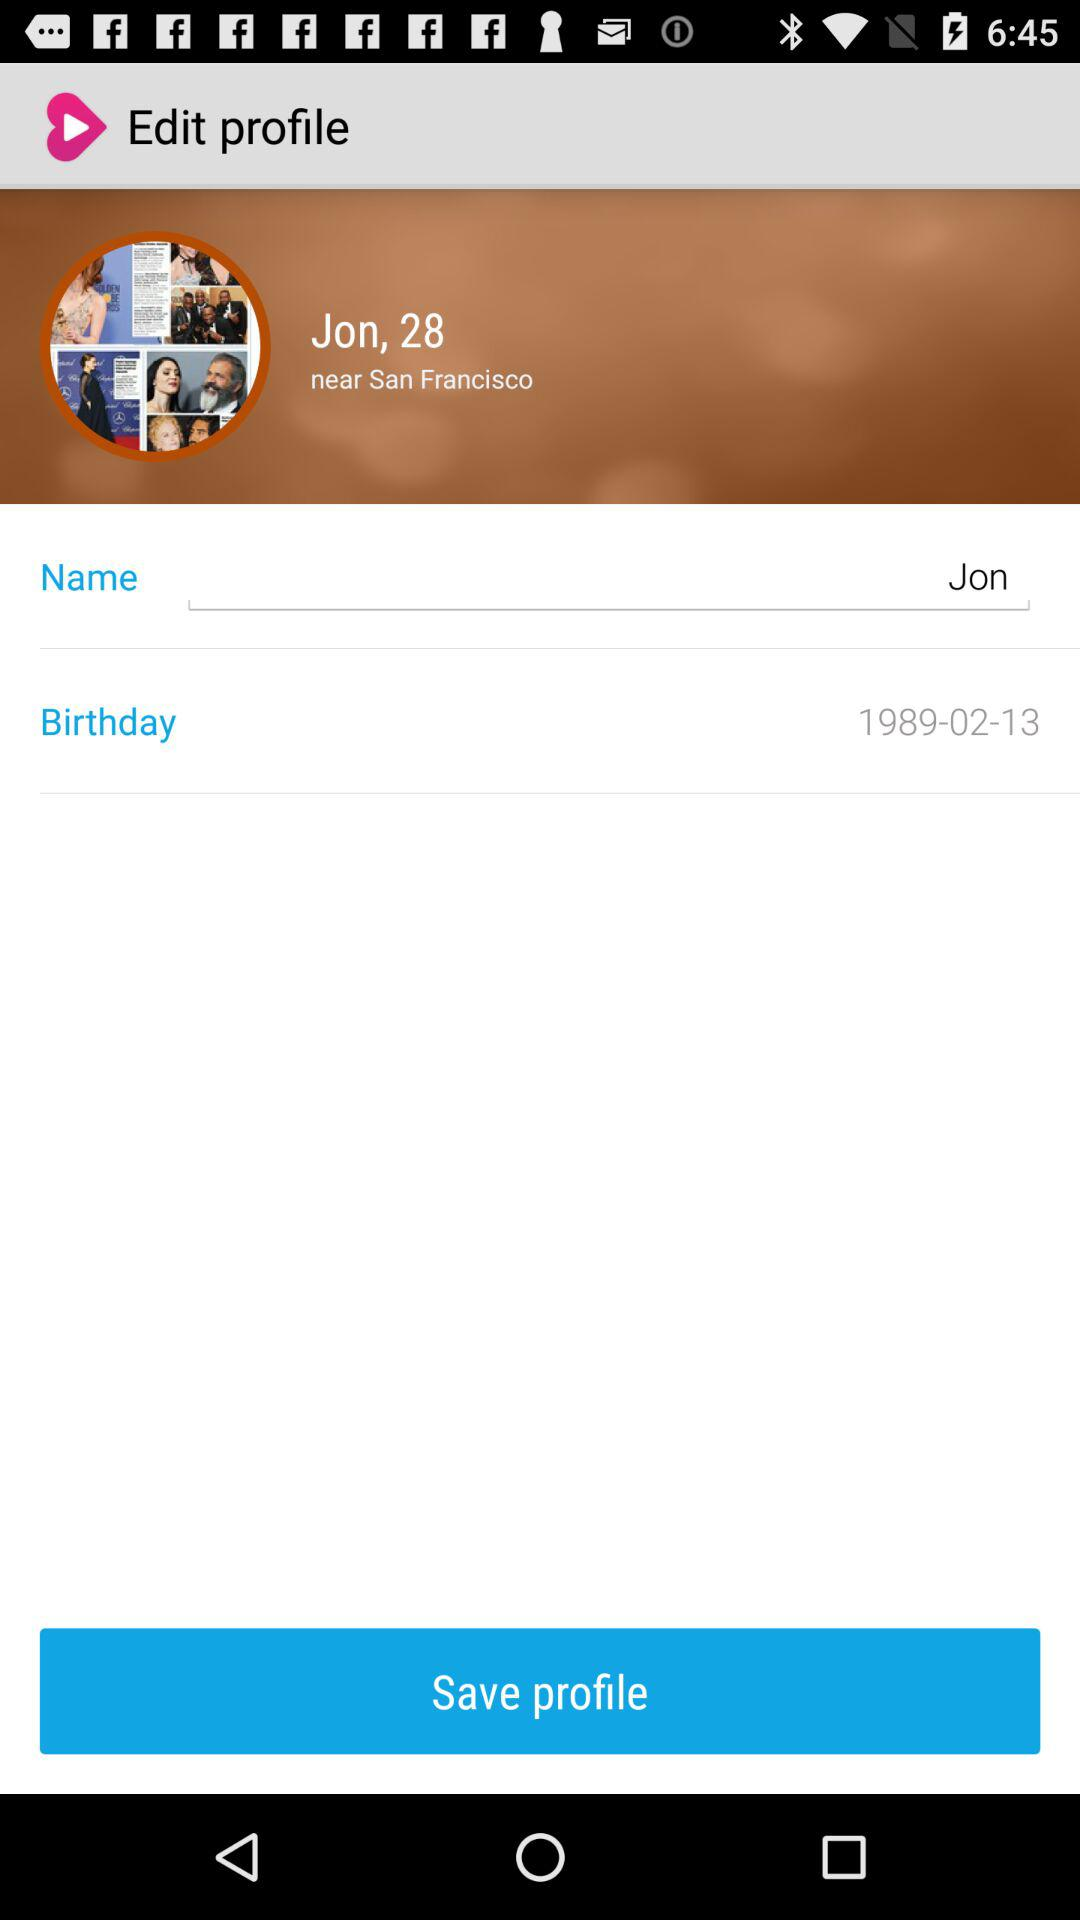What is the date of birth? The date of birth is 1989-02-13. 